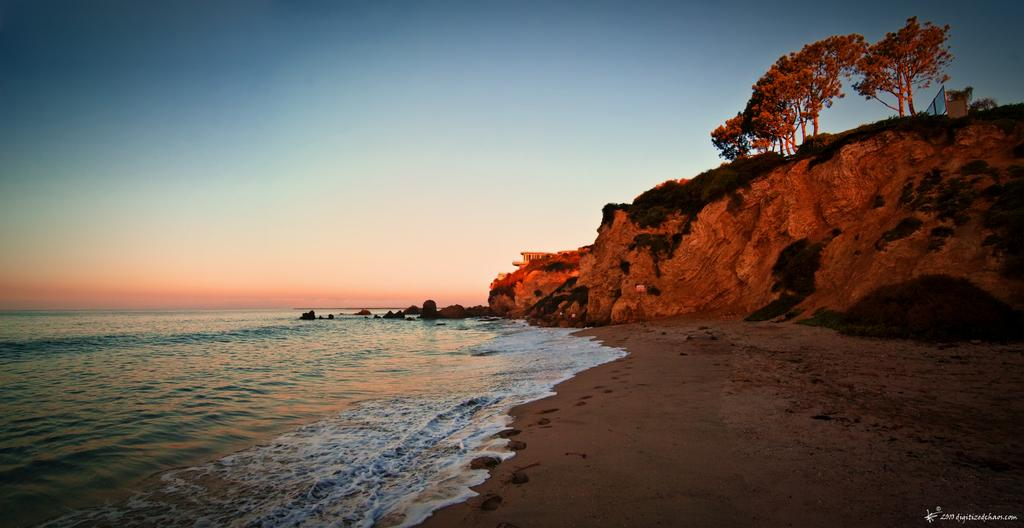What is one of the natural elements present in the image? There is water in the image. What type of vegetation can be seen in the image? There are trees and plants in the image. What other geological features are present in the image? There are rocks in the image. What color is the sky in the image? The sky is blue in the image. Where can the text be found in the image? The text is located at the bottom right corner of the image. Can you see a cave in the image? There is no cave present in the image. What type of seashore can be seen in the image? The image does not depict a seashore; it features water, trees, plants, rocks, and a blue sky. 